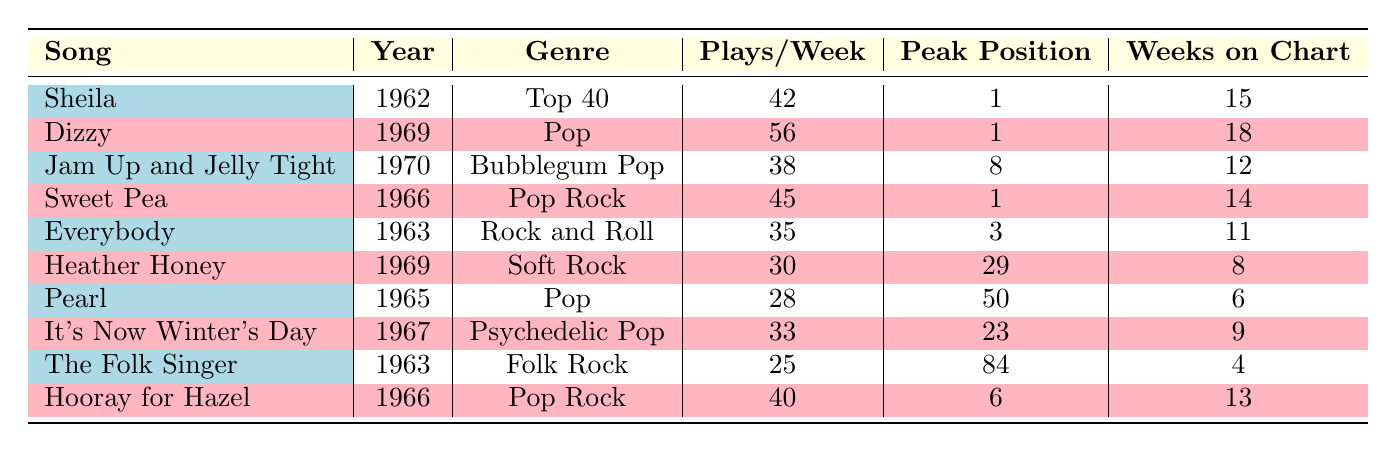What was the peak chart position of "Sweet Pea"? By looking at the row for "Sweet Pea," I can see that the peak chart position is listed as 1.
Answer: 1 Which song had the most plays per week? The song "Dizzy" has the highest plays per week listed at 56. All other songs have fewer plays per week.
Answer: Dizzy (56) How many weeks did "Heather Honey" stay on the chart? The table shows that "Heather Honey" was on the chart for 8 weeks.
Answer: 8 Is the genre of "Jam Up and Jelly Tight" Bubblegum Pop? Looking at the genre column for the song "Jam Up and Jelly Tight," it is indeed labeled as "Bubblegum Pop."
Answer: Yes What is the average number of plays per week for songs that reached the peak position of 1? The songs that reached peak position 1 are "Sheila," "Dizzy," and "Sweet Pea." Their plays per week are 42, 56, and 45 respectively. The average is calculated as (42 + 56 + 45) / 3 = 47.67, which rounds to 48.
Answer: 48 Which song had the longest stay on the chart? To determine this, I compare the "Weeks on Chart" for all songs. "Dizzy" had the longest stay with 18 weeks, followed by "Sheila" with 15 weeks.
Answer: Dizzy (18) Did "Everybody" reach a peak position higher than 3? The table shows that "Everybody" peaked at position 3, so it did not achieve a peak higher than that.
Answer: No How many songs chartered in the Pop genre? By counting the relevant rows in the genre column, I find there are three songs listed as Pop: "Dizzy," "Sweet Pea," and "Heather Honey."
Answer: 3 What is the total number of weeks on chart for the songs from the year 1966? The songs from 1966 are "Sweet Pea" (14 weeks) and "Hooray for Hazel" (13 weeks). Adding these together: 14 + 13 = 27.
Answer: 27 